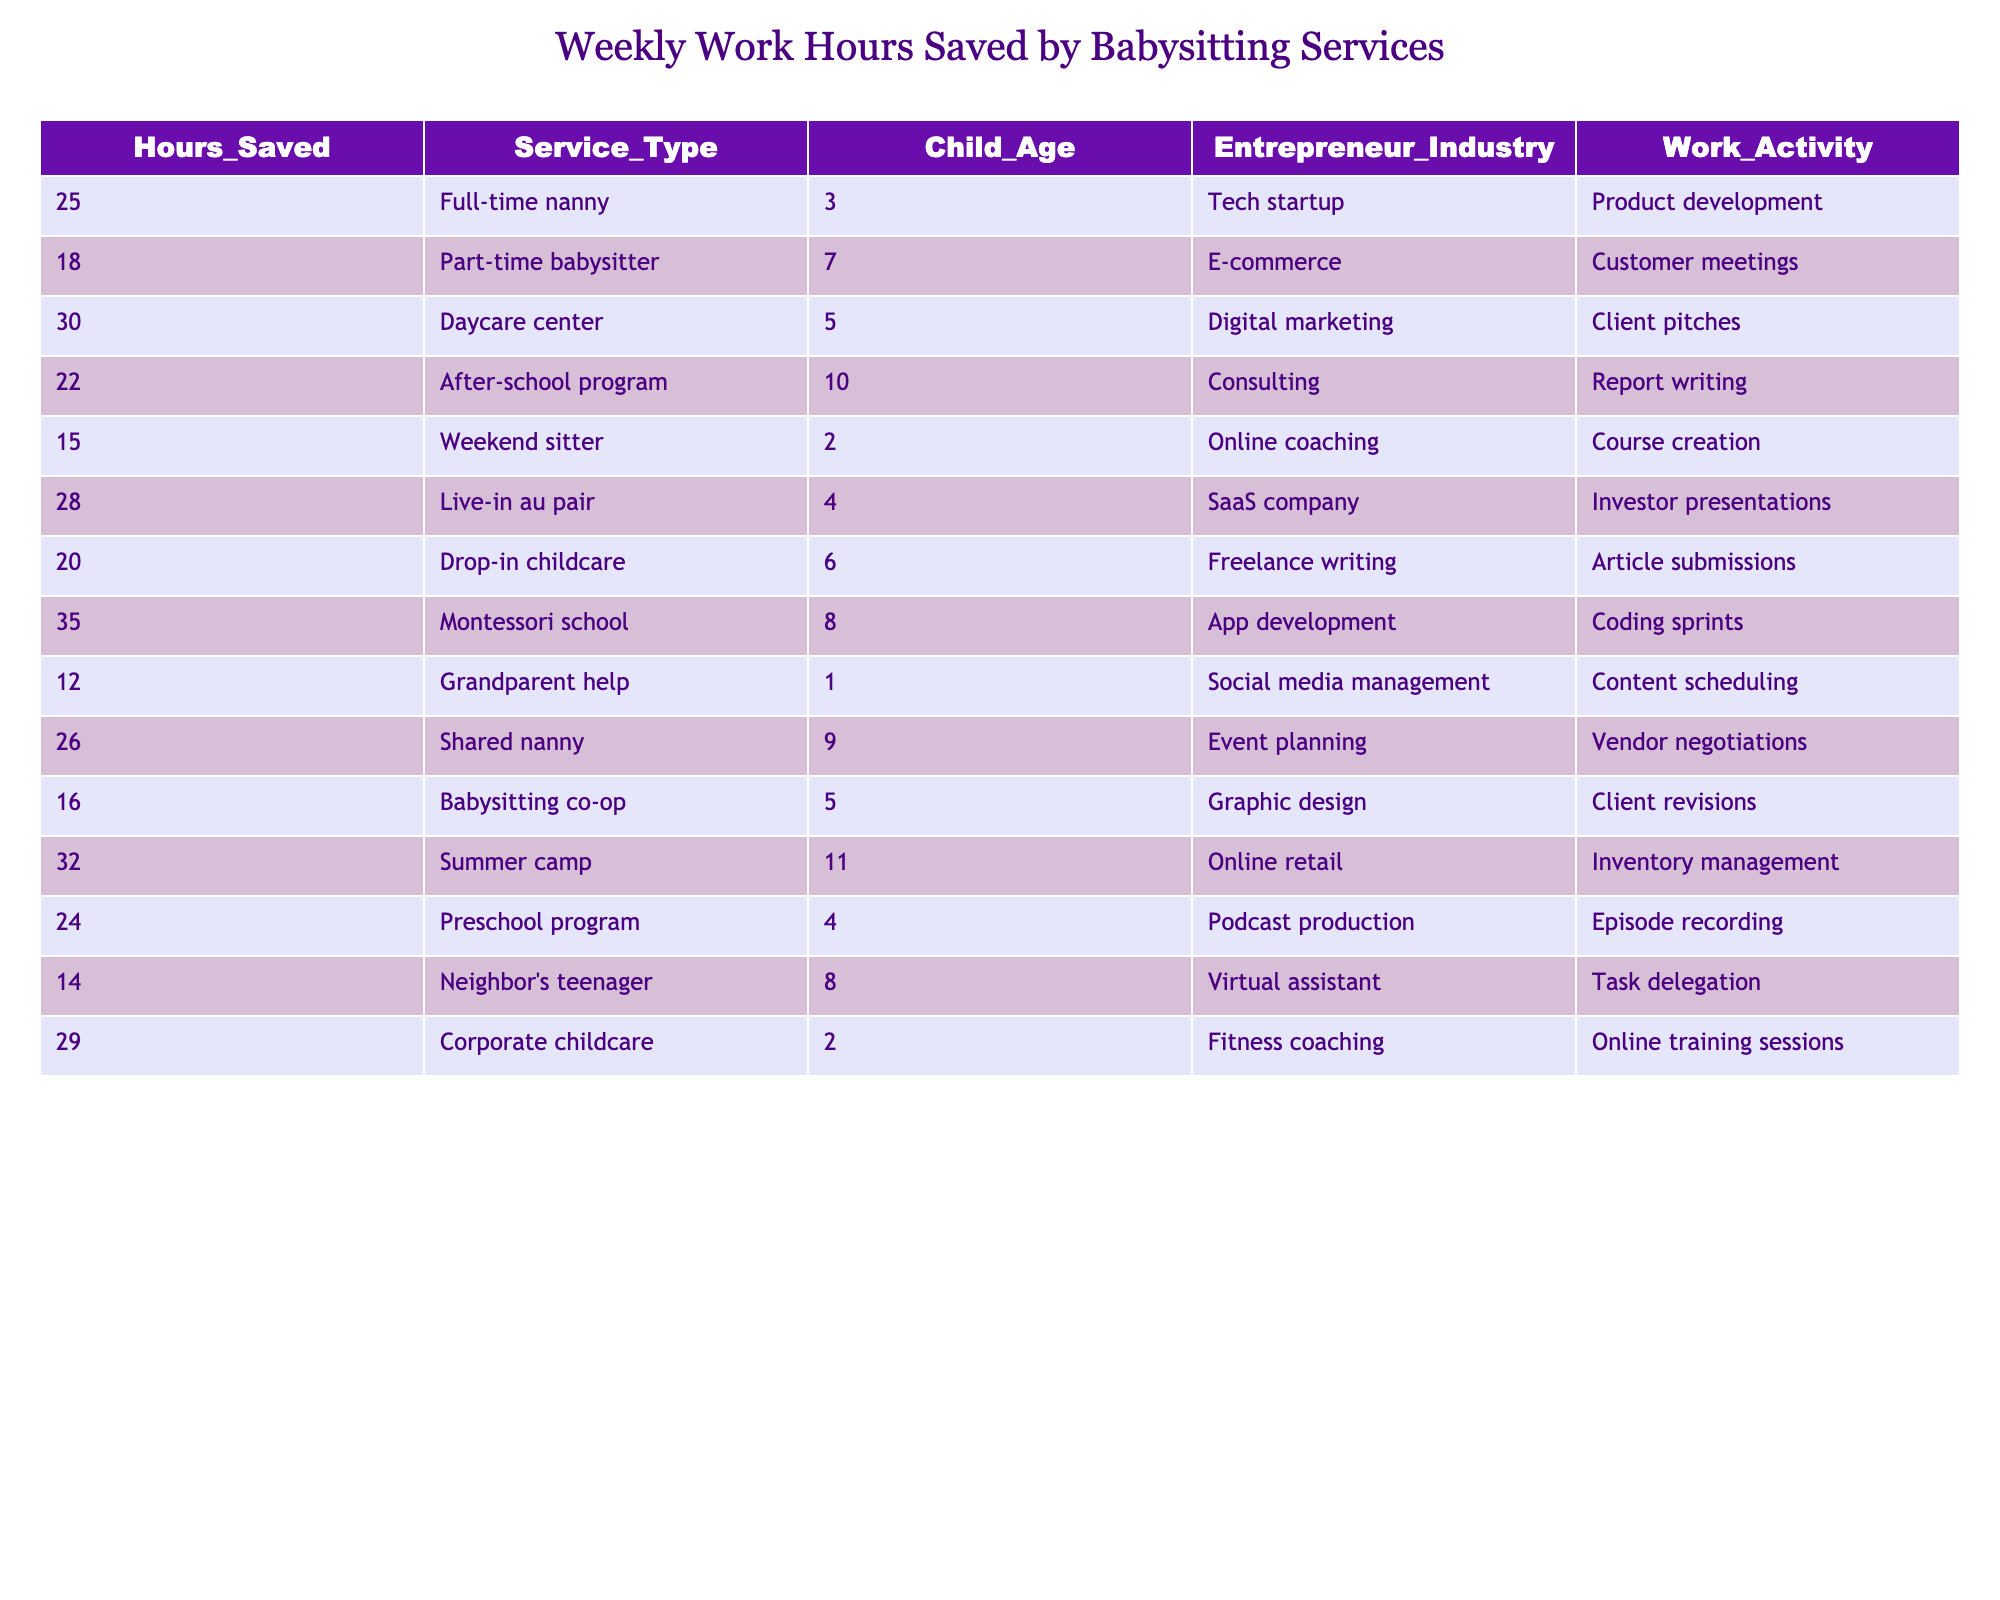What is the maximum number of hours saved by utilizing a babysitting service? The maximum value in the "Hours_Saved" column is 35, which corresponds to the Montessori school service type.
Answer: 35 Which service type saved the least amount of work hours? Looking at the "Hours_Saved" column, the minimum value is 12, which relates to "Grandparent help".
Answer: 12 How many hours are saved on average when using a full-time nanny compared to a part-time babysitter? The hours saved by a full-time nanny are 25, and for a part-time babysitter, it is 18. So, the difference is 25 - 18 = 7 hours.
Answer: 7 Is the amount of hours saved higher with daycare centers than with live-in au pairs? Daycare centers save 30 hours while live-in au pairs save 28 hours. Since 30 hours is greater than 28 hours, the statement is true.
Answer: Yes What’s the total number of hours saved by utilizing all types of weekend services? The table shows that the weekend sitter saves 15 hours. Since there are no other weekend services listed, the total is just 15 hours.
Answer: 15 Which industry uses the service that saves the most hours, and what is that number? The Montessori school in the app development industry saves the most hours at 35. Checking the "Entrepreneur_Industry" corresponding to the maximum "Hours_Saved" gives us this information.
Answer: App development, 35 How many service types save more than 20 hours? The service types that save more than 20 hours are full-time nanny (25), daycare center (30), after-school program (22), live-in au pair (28), Montessori school (35), and shared nanny (26), totaling to 6 services.
Answer: 6 What is the difference between the highest and lowest hours saved in the table? The maximum hours saved is 35 (Montessori school) and the minimum is 12 (Grandparent help). The difference is calculated as 35 - 12 = 23.
Answer: 23 Are there more services that save more than 25 hours compared to those that save less than 20 hours? Services saving more than 25 hours are full-time nanny (25), daycare center (30), Montessori school (35), and live-in au pair (28), totaling 4. Services saving less than 20 hours are grandparent help (12) and neighbor's teenager (14), totaling 2. Since 4 is more than 2, the answer is yes.
Answer: Yes What is the total work hours saved by all types of after-school programs? The only after-school program listed is the one that saves 22 hours. Therefore, the total hours saved by all after-school programs is 22.
Answer: 22 